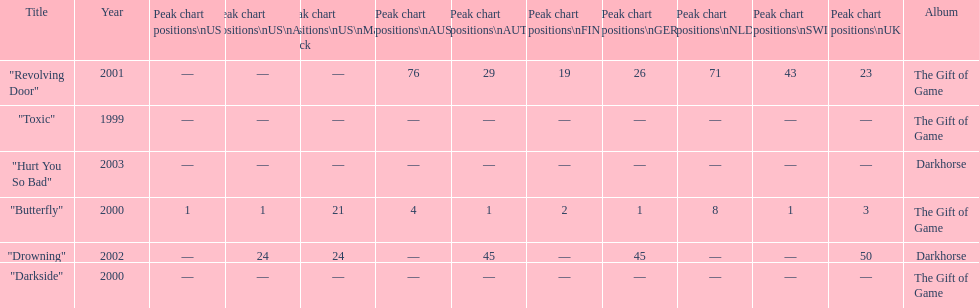How many times did the single "butterfly" rank as 1 in the chart? 5. 